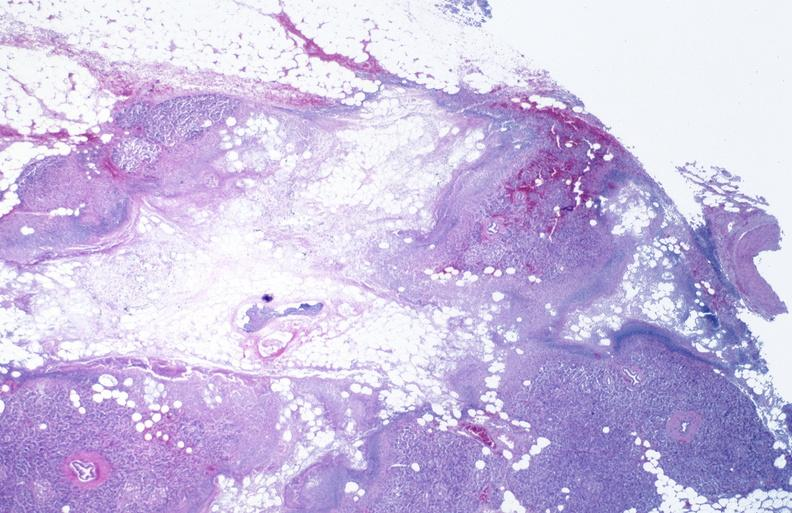does this image show pancreatic fat necrosis?
Answer the question using a single word or phrase. Yes 